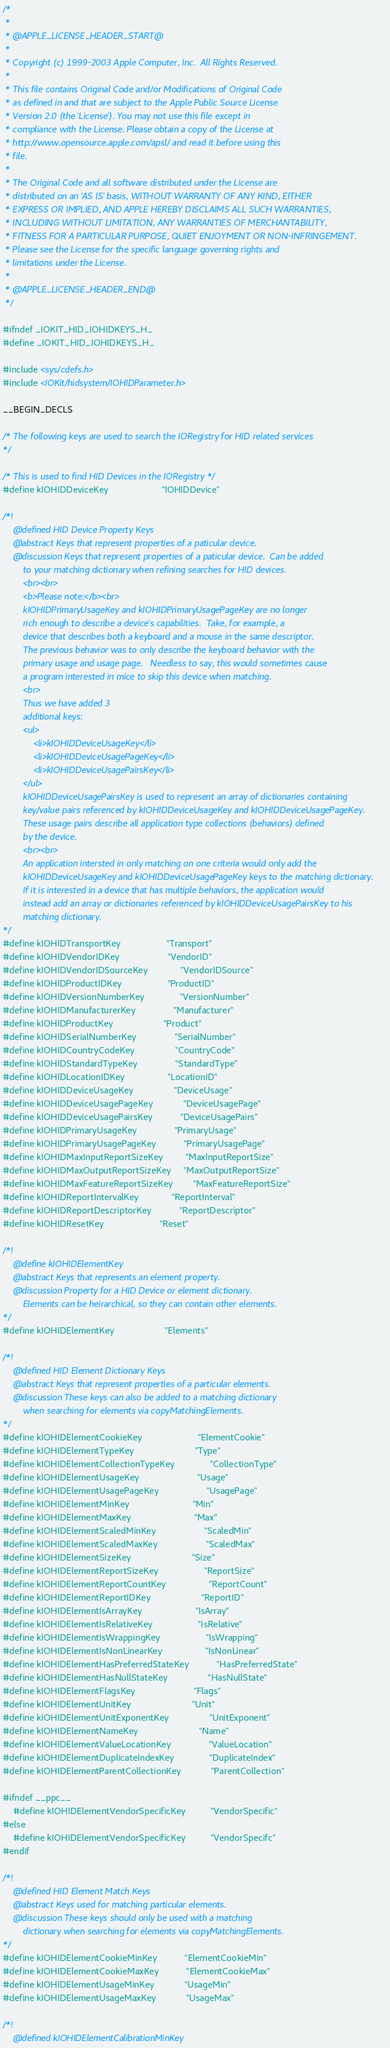<code> <loc_0><loc_0><loc_500><loc_500><_C_>/*
 *
 * @APPLE_LICENSE_HEADER_START@
 * 
 * Copyright (c) 1999-2003 Apple Computer, Inc.  All Rights Reserved.
 * 
 * This file contains Original Code and/or Modifications of Original Code
 * as defined in and that are subject to the Apple Public Source License
 * Version 2.0 (the 'License'). You may not use this file except in
 * compliance with the License. Please obtain a copy of the License at
 * http://www.opensource.apple.com/apsl/ and read it before using this
 * file.
 * 
 * The Original Code and all software distributed under the License are
 * distributed on an 'AS IS' basis, WITHOUT WARRANTY OF ANY KIND, EITHER
 * EXPRESS OR IMPLIED, AND APPLE HEREBY DISCLAIMS ALL SUCH WARRANTIES,
 * INCLUDING WITHOUT LIMITATION, ANY WARRANTIES OF MERCHANTABILITY,
 * FITNESS FOR A PARTICULAR PURPOSE, QUIET ENJOYMENT OR NON-INFRINGEMENT.
 * Please see the License for the specific language governing rights and
 * limitations under the License.
 * 
 * @APPLE_LICENSE_HEADER_END@
 */

#ifndef _IOKIT_HID_IOHIDKEYS_H_
#define _IOKIT_HID_IOHIDKEYS_H_

#include <sys/cdefs.h>
#include <IOKit/hidsystem/IOHIDParameter.h>

__BEGIN_DECLS

/* The following keys are used to search the IORegistry for HID related services
*/

/* This is used to find HID Devices in the IORegistry */
#define kIOHIDDeviceKey                     "IOHIDDevice"

/*!
    @defined HID Device Property Keys
    @abstract Keys that represent properties of a paticular device.
    @discussion Keys that represent properties of a paticular device.  Can be added
        to your matching dictionary when refining searches for HID devices.
        <br><br>
        <b>Please note:</b><br>
        kIOHIDPrimaryUsageKey and kIOHIDPrimaryUsagePageKey are no longer 
        rich enough to describe a device's capabilities.  Take, for example, a
        device that describes both a keyboard and a mouse in the same descriptor.  
        The previous behavior was to only describe the keyboard behavior with the 
        primary usage and usage page.   Needless to say, this would sometimes cause 
        a program interested in mice to skip this device when matching.  
        <br>
        Thus we have added 3 
        additional keys:
        <ul>
            <li>kIOHIDDeviceUsageKey</li>
            <li>kIOHIDDeviceUsagePageKey</li>
            <li>kIOHIDDeviceUsagePairsKey</li>
        </ul>
        kIOHIDDeviceUsagePairsKey is used to represent an array of dictionaries containing 
        key/value pairs referenced by kIOHIDDeviceUsageKey and kIOHIDDeviceUsagePageKey.  
        These usage pairs describe all application type collections (behaviors) defined 
        by the device.
        <br><br>
        An application intersted in only matching on one criteria would only add the 
        kIOHIDDeviceUsageKey and kIOHIDDeviceUsagePageKey keys to the matching dictionary.
        If it is interested in a device that has multiple behaviors, the application would
        instead add an array or dictionaries referenced by kIOHIDDeviceUsagePairsKey to his 
        matching dictionary.
*/
#define kIOHIDTransportKey                  "Transport"
#define kIOHIDVendorIDKey                   "VendorID"
#define kIOHIDVendorIDSourceKey             "VendorIDSource"
#define kIOHIDProductIDKey                  "ProductID"
#define kIOHIDVersionNumberKey              "VersionNumber"
#define kIOHIDManufacturerKey               "Manufacturer"
#define kIOHIDProductKey                    "Product"
#define kIOHIDSerialNumberKey               "SerialNumber"
#define kIOHIDCountryCodeKey                "CountryCode"
#define kIOHIDStandardTypeKey               "StandardType"
#define kIOHIDLocationIDKey                 "LocationID"
#define kIOHIDDeviceUsageKey                "DeviceUsage"
#define kIOHIDDeviceUsagePageKey            "DeviceUsagePage"
#define kIOHIDDeviceUsagePairsKey           "DeviceUsagePairs"
#define kIOHIDPrimaryUsageKey               "PrimaryUsage"
#define kIOHIDPrimaryUsagePageKey           "PrimaryUsagePage"
#define kIOHIDMaxInputReportSizeKey         "MaxInputReportSize"
#define kIOHIDMaxOutputReportSizeKey	    "MaxOutputReportSize"
#define kIOHIDMaxFeatureReportSizeKey	    "MaxFeatureReportSize"
#define kIOHIDReportIntervalKey             "ReportInterval"
#define kIOHIDReportDescriptorKey           "ReportDescriptor"
#define kIOHIDResetKey                      "Reset"

/*!
    @define kIOHIDElementKey
    @abstract Keys that represents an element property.
    @discussion Property for a HID Device or element dictionary.
        Elements can be heirarchical, so they can contain other elements.
*/
#define kIOHIDElementKey                    "Elements"

/*!
    @defined HID Element Dictionary Keys
    @abstract Keys that represent properties of a particular elements.
    @discussion These keys can also be added to a matching dictionary 
        when searching for elements via copyMatchingElements.  
*/
#define kIOHIDElementCookieKey                      "ElementCookie"
#define kIOHIDElementTypeKey                        "Type"
#define kIOHIDElementCollectionTypeKey              "CollectionType"
#define kIOHIDElementUsageKey                       "Usage"
#define kIOHIDElementUsagePageKey                   "UsagePage"
#define kIOHIDElementMinKey                         "Min"
#define kIOHIDElementMaxKey                         "Max"
#define kIOHIDElementScaledMinKey                   "ScaledMin"
#define kIOHIDElementScaledMaxKey                   "ScaledMax"
#define kIOHIDElementSizeKey                        "Size"
#define kIOHIDElementReportSizeKey                  "ReportSize"
#define kIOHIDElementReportCountKey                 "ReportCount"
#define kIOHIDElementReportIDKey                    "ReportID"
#define kIOHIDElementIsArrayKey                     "IsArray"
#define kIOHIDElementIsRelativeKey                  "IsRelative"
#define kIOHIDElementIsWrappingKey                  "IsWrapping"
#define kIOHIDElementIsNonLinearKey                 "IsNonLinear"
#define kIOHIDElementHasPreferredStateKey           "HasPreferredState"
#define kIOHIDElementHasNullStateKey                "HasNullState"
#define kIOHIDElementFlagsKey                       "Flags"
#define kIOHIDElementUnitKey                        "Unit"
#define kIOHIDElementUnitExponentKey                "UnitExponent"
#define kIOHIDElementNameKey                        "Name"
#define kIOHIDElementValueLocationKey               "ValueLocation"
#define kIOHIDElementDuplicateIndexKey              "DuplicateIndex"
#define kIOHIDElementParentCollectionKey            "ParentCollection"

#ifndef __ppc__
    #define kIOHIDElementVendorSpecificKey          "VendorSpecific"
#else
    #define kIOHIDElementVendorSpecificKey          "VendorSpecifc"
#endif

/*!
    @defined HID Element Match Keys
    @abstract Keys used for matching particular elements.
    @discussion These keys should only be used with a matching  
        dictionary when searching for elements via copyMatchingElements.  
*/
#define kIOHIDElementCookieMinKey           "ElementCookieMin"
#define kIOHIDElementCookieMaxKey           "ElementCookieMax"
#define kIOHIDElementUsageMinKey            "UsageMin"
#define kIOHIDElementUsageMaxKey            "UsageMax"

/*!
    @defined kIOHIDElementCalibrationMinKey</code> 